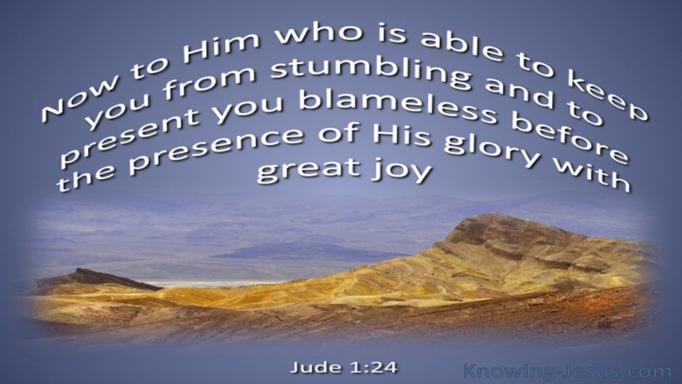What is the Bible verse mentioned in the image? The image features the Bible verse Jude 1:24, which says, 'Now to Him who is able to keep you from stumbling, and to present you blameless before the presence of His glory with great joy.' This verse expresses a profound assurance in God's protective and redemptive power. 